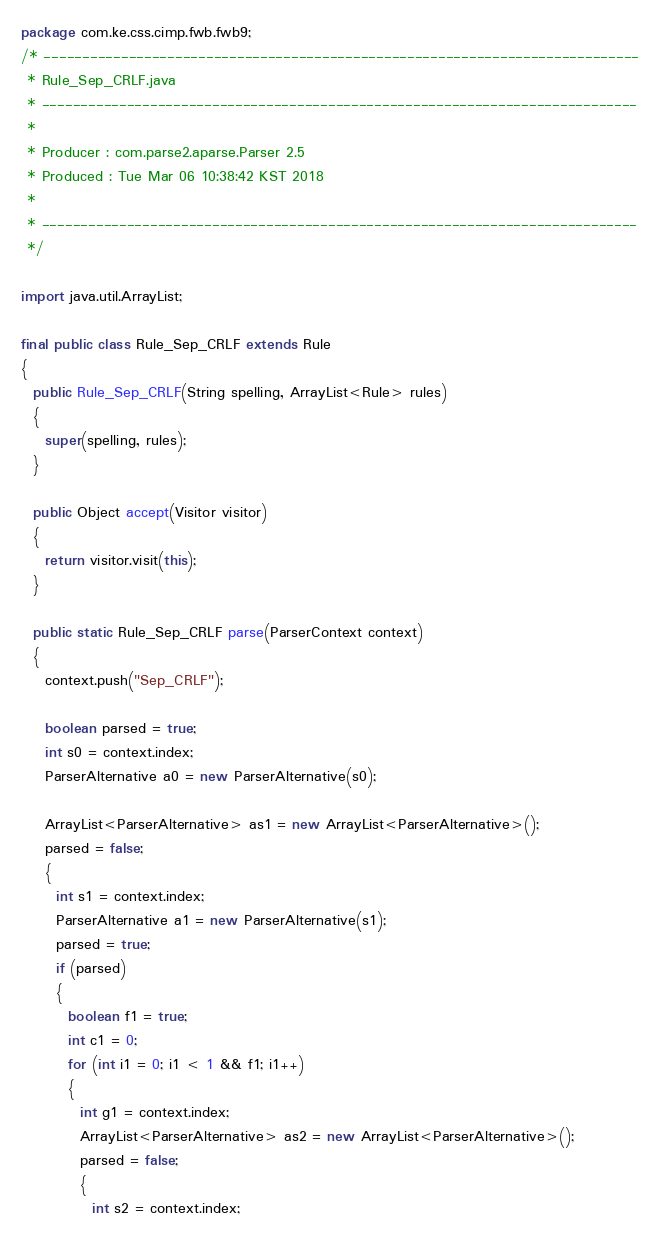<code> <loc_0><loc_0><loc_500><loc_500><_Java_>package com.ke.css.cimp.fwb.fwb9;
/* -----------------------------------------------------------------------------
 * Rule_Sep_CRLF.java
 * -----------------------------------------------------------------------------
 *
 * Producer : com.parse2.aparse.Parser 2.5
 * Produced : Tue Mar 06 10:38:42 KST 2018
 *
 * -----------------------------------------------------------------------------
 */

import java.util.ArrayList;

final public class Rule_Sep_CRLF extends Rule
{
  public Rule_Sep_CRLF(String spelling, ArrayList<Rule> rules)
  {
    super(spelling, rules);
  }

  public Object accept(Visitor visitor)
  {
    return visitor.visit(this);
  }

  public static Rule_Sep_CRLF parse(ParserContext context)
  {
    context.push("Sep_CRLF");

    boolean parsed = true;
    int s0 = context.index;
    ParserAlternative a0 = new ParserAlternative(s0);

    ArrayList<ParserAlternative> as1 = new ArrayList<ParserAlternative>();
    parsed = false;
    {
      int s1 = context.index;
      ParserAlternative a1 = new ParserAlternative(s1);
      parsed = true;
      if (parsed)
      {
        boolean f1 = true;
        int c1 = 0;
        for (int i1 = 0; i1 < 1 && f1; i1++)
        {
          int g1 = context.index;
          ArrayList<ParserAlternative> as2 = new ArrayList<ParserAlternative>();
          parsed = false;
          {
            int s2 = context.index;</code> 